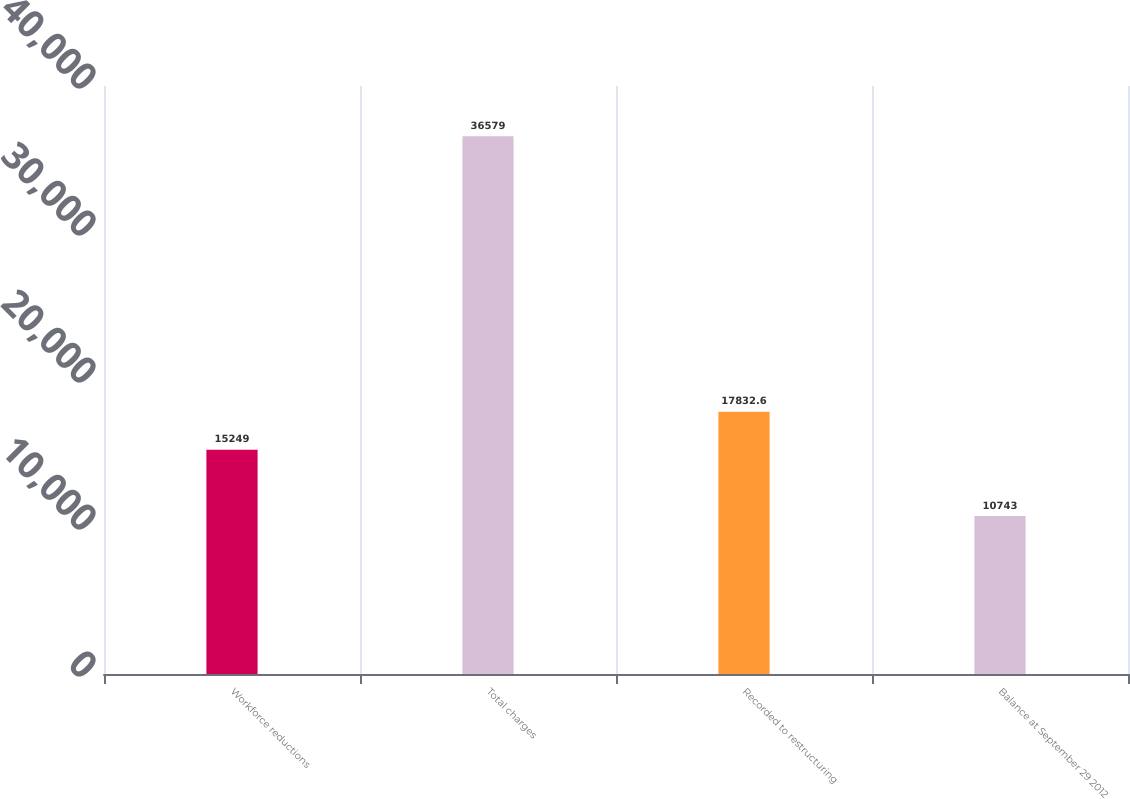<chart> <loc_0><loc_0><loc_500><loc_500><bar_chart><fcel>Workforce reductions<fcel>Total charges<fcel>Recorded to restructuring<fcel>Balance at September 29 2012<nl><fcel>15249<fcel>36579<fcel>17832.6<fcel>10743<nl></chart> 